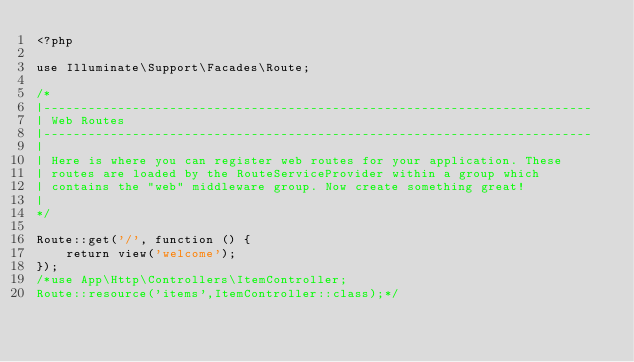<code> <loc_0><loc_0><loc_500><loc_500><_PHP_><?php

use Illuminate\Support\Facades\Route;

/*
|--------------------------------------------------------------------------
| Web Routes
|--------------------------------------------------------------------------
|
| Here is where you can register web routes for your application. These
| routes are loaded by the RouteServiceProvider within a group which
| contains the "web" middleware group. Now create something great!
|
*/

Route::get('/', function () {
    return view('welcome');
});
/*use App\Http\Controllers\ItemController;
Route::resource('items',ItemController::class);*/
</code> 